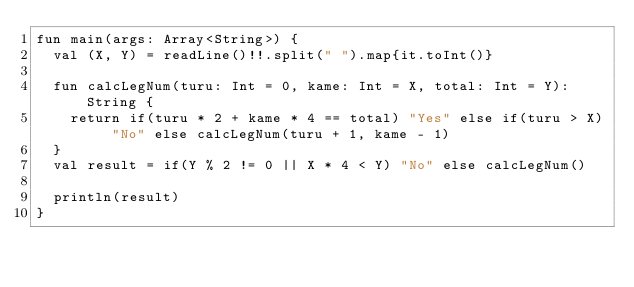<code> <loc_0><loc_0><loc_500><loc_500><_Kotlin_>fun main(args: Array<String>) {
  val (X, Y) = readLine()!!.split(" ").map{it.toInt()}
  
  fun calcLegNum(turu: Int = 0, kame: Int = X, total: Int = Y): String {
    return if(turu * 2 + kame * 4 == total) "Yes" else if(turu > X) "No" else calcLegNum(turu + 1, kame - 1)
  }
  val result = if(Y % 2 != 0 || X * 4 < Y) "No" else calcLegNum()
  
  println(result)
}</code> 